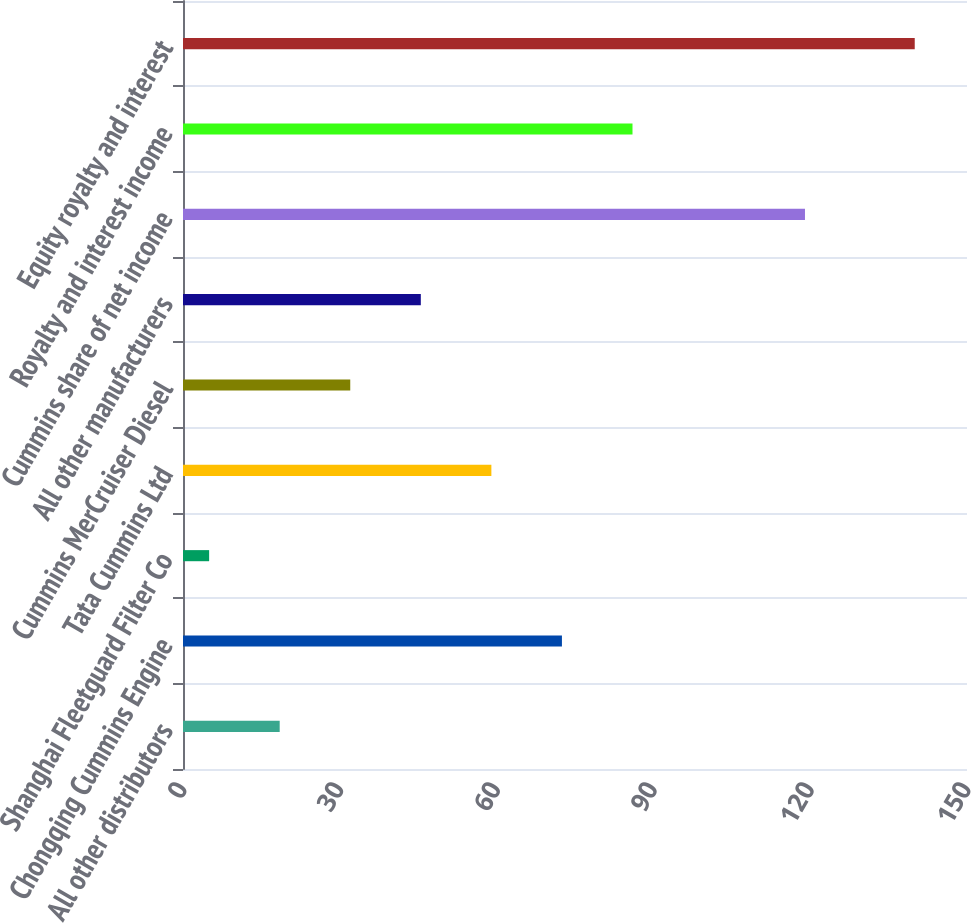Convert chart. <chart><loc_0><loc_0><loc_500><loc_500><bar_chart><fcel>All other distributors<fcel>Chongqing Cummins Engine<fcel>Shanghai Fleetguard Filter Co<fcel>Tata Cummins Ltd<fcel>Cummins MerCruiser Diesel<fcel>All other manufacturers<fcel>Cummins share of net income<fcel>Royalty and interest income<fcel>Equity royalty and interest<nl><fcel>18.5<fcel>72.5<fcel>5<fcel>59<fcel>32<fcel>45.5<fcel>119<fcel>86<fcel>140<nl></chart> 